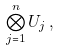Convert formula to latex. <formula><loc_0><loc_0><loc_500><loc_500>\bigotimes _ { j = 1 } ^ { n } U _ { j } \, ,</formula> 